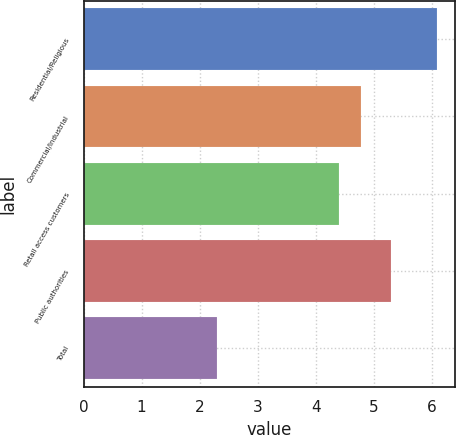Convert chart to OTSL. <chart><loc_0><loc_0><loc_500><loc_500><bar_chart><fcel>Residential/Religious<fcel>Commercial/Industrial<fcel>Retail access customers<fcel>Public authorities<fcel>Total<nl><fcel>6.1<fcel>4.78<fcel>4.4<fcel>5.3<fcel>2.3<nl></chart> 